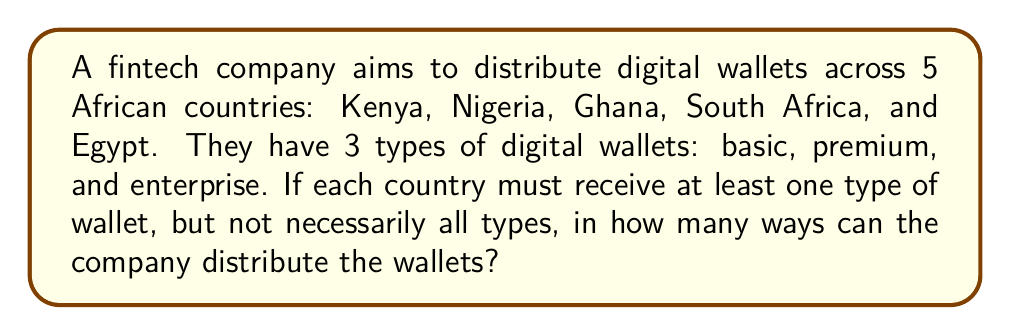Solve this math problem. Let's approach this step-by-step:

1) This is a problem of distributing distinct objects (3 types of wallets) into distinct boxes (5 countries), where each box must have at least one object.

2) We can use the concept of surjective functions. The number of ways to distribute the wallets is equal to the number of surjective functions from the set of wallet types to the set of countries.

3) The formula for the number of surjective functions from a set of size m to a set of size n (where m ≥ n) is:

   $$\sum_{k=0}^n (-1)^k \binom{n}{k} (n-k)^m$$

4) In our case, m = 3 (wallet types) and n = 5 (countries).

5) Let's calculate each term:

   For k = 0: $\binom{5}{0} (5-0)^3 = 1 \cdot 125 = 125$
   For k = 1: $\binom{5}{1} (5-1)^3 = 5 \cdot 64 = 320$
   For k = 2: $\binom{5}{2} (5-2)^3 = 10 \cdot 27 = 270$
   For k = 3: $\binom{5}{3} (5-3)^3 = 10 \cdot 8 = 80$
   For k = 4: $\binom{5}{4} (5-4)^3 = 5 \cdot 1 = 5$
   For k = 5: $\binom{5}{5} (5-5)^3 = 1 \cdot 0 = 0$

6) Now, we apply the alternating sum:

   $125 - 320 + 270 - 80 + 5 - 0 = 0$

7) Therefore, there are 0 ways to distribute the wallets under these conditions.

8) This result makes sense because it's impossible to distribute 3 types of wallets to 5 countries with each country receiving at least one type. There aren't enough wallet types to satisfy this condition.
Answer: 0 